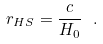<formula> <loc_0><loc_0><loc_500><loc_500>r _ { H S } = { \frac { c } { H _ { 0 } } } \ .</formula> 